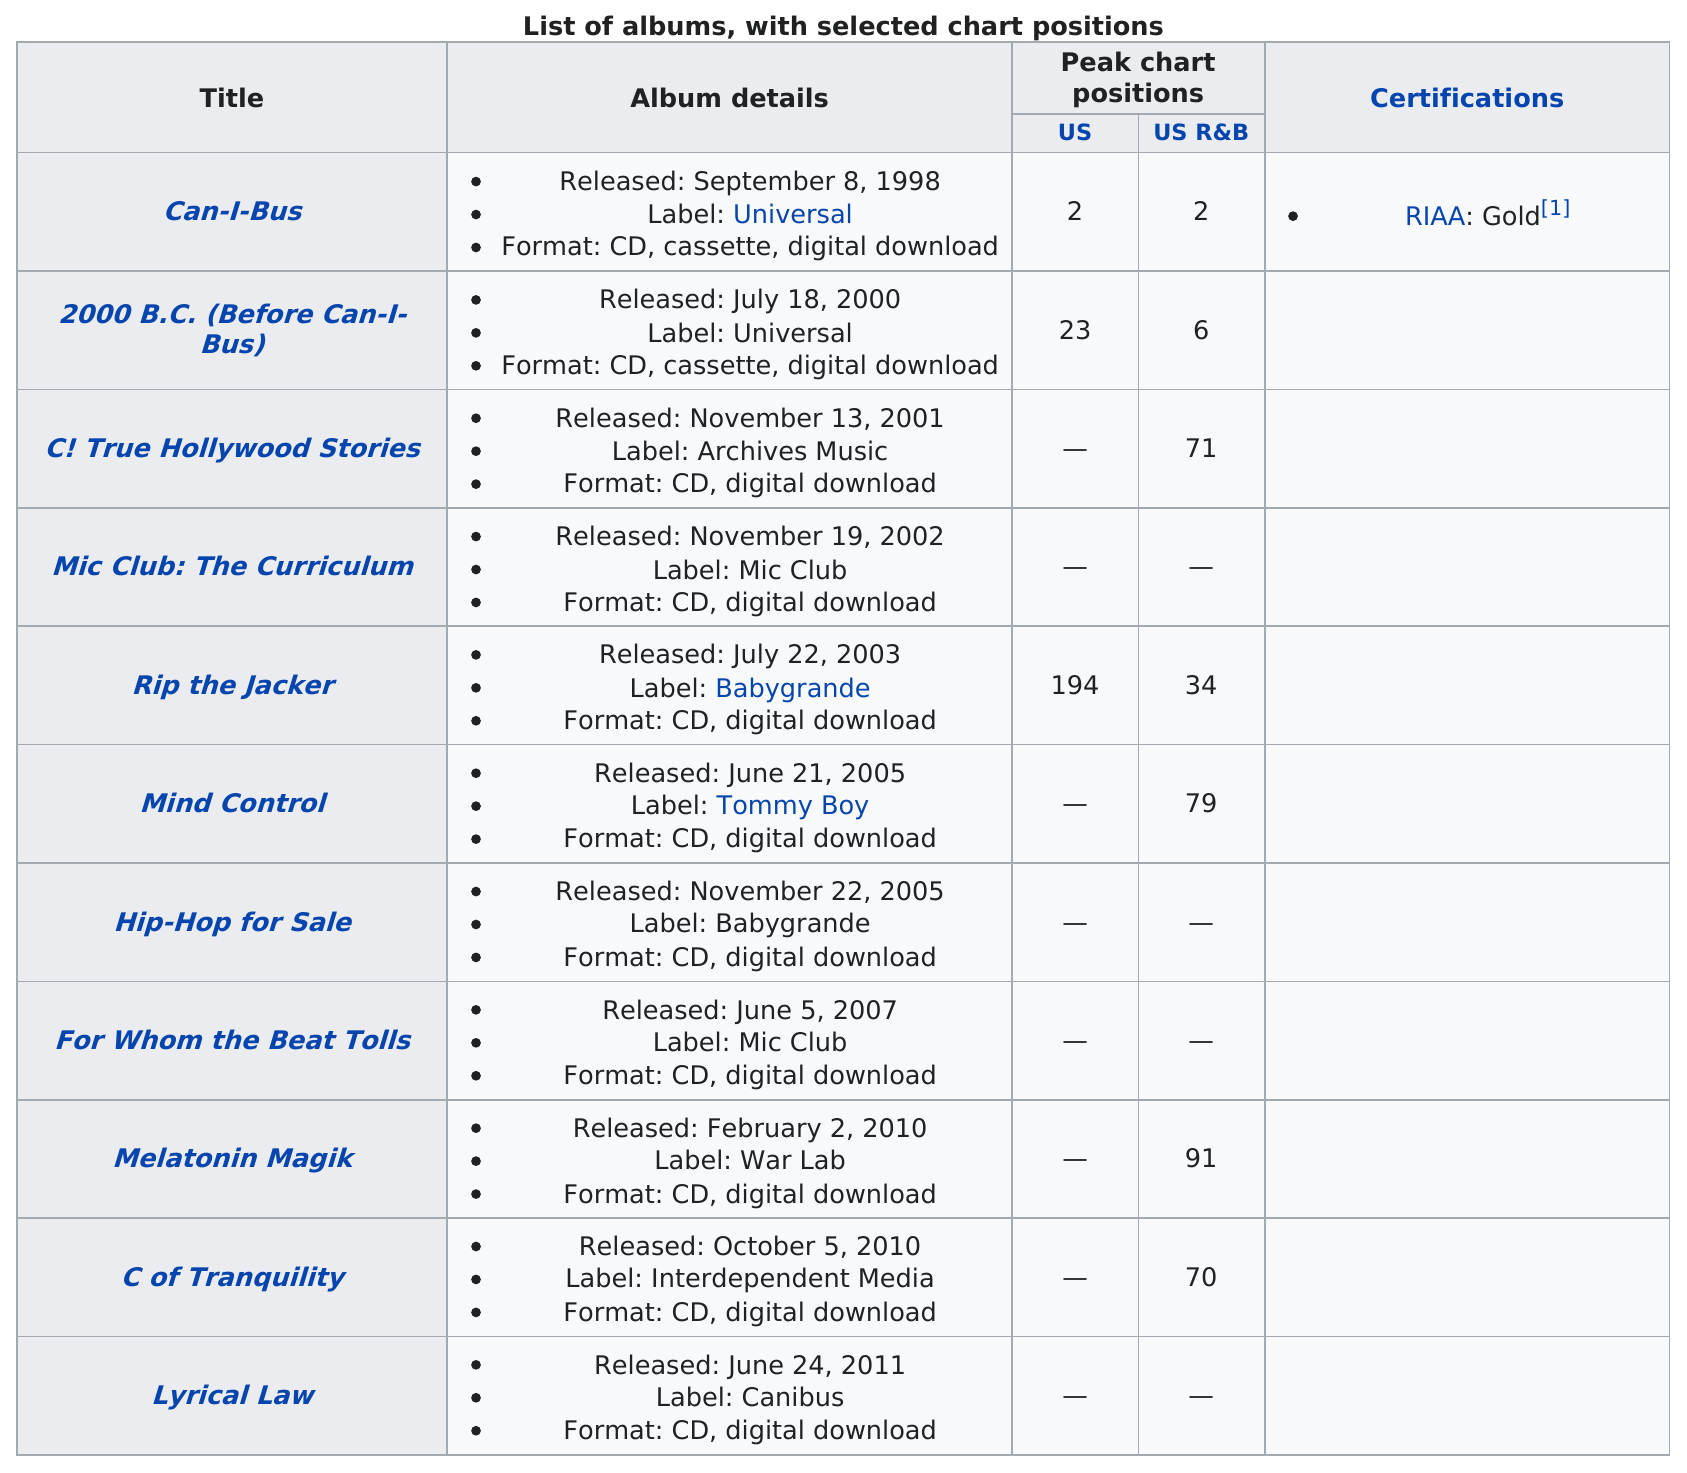Mention a couple of crucial points in this snapshot. The total number of albums that Can-i-bus has released is 11. The number of times a Can-I-Bus album reached the top 10 on the US charts is 1. After the year 2000, Can-i-bus released a total of 9 albums. The last album produced was "Lyrical Law. What was the highest position an album reached on either chart? 